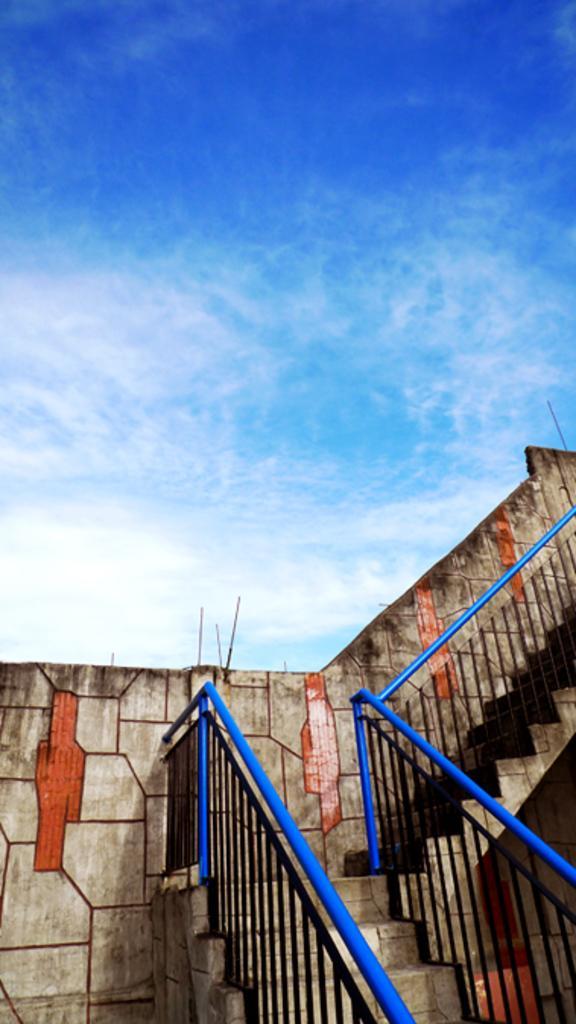How would you summarize this image in a sentence or two? In the foreground of this image, there are stairs, railing and the wall. On the top, there is the sky and the cloud. 